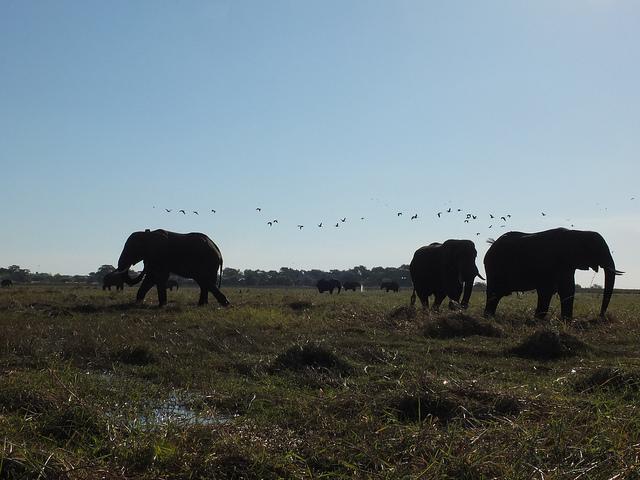How many bulls are in the picture?
Give a very brief answer. 0. How many animals are in this photo?
Give a very brief answer. 3. How many elephants are there?
Give a very brief answer. 3. How many surfboards are in the background?
Give a very brief answer. 0. 